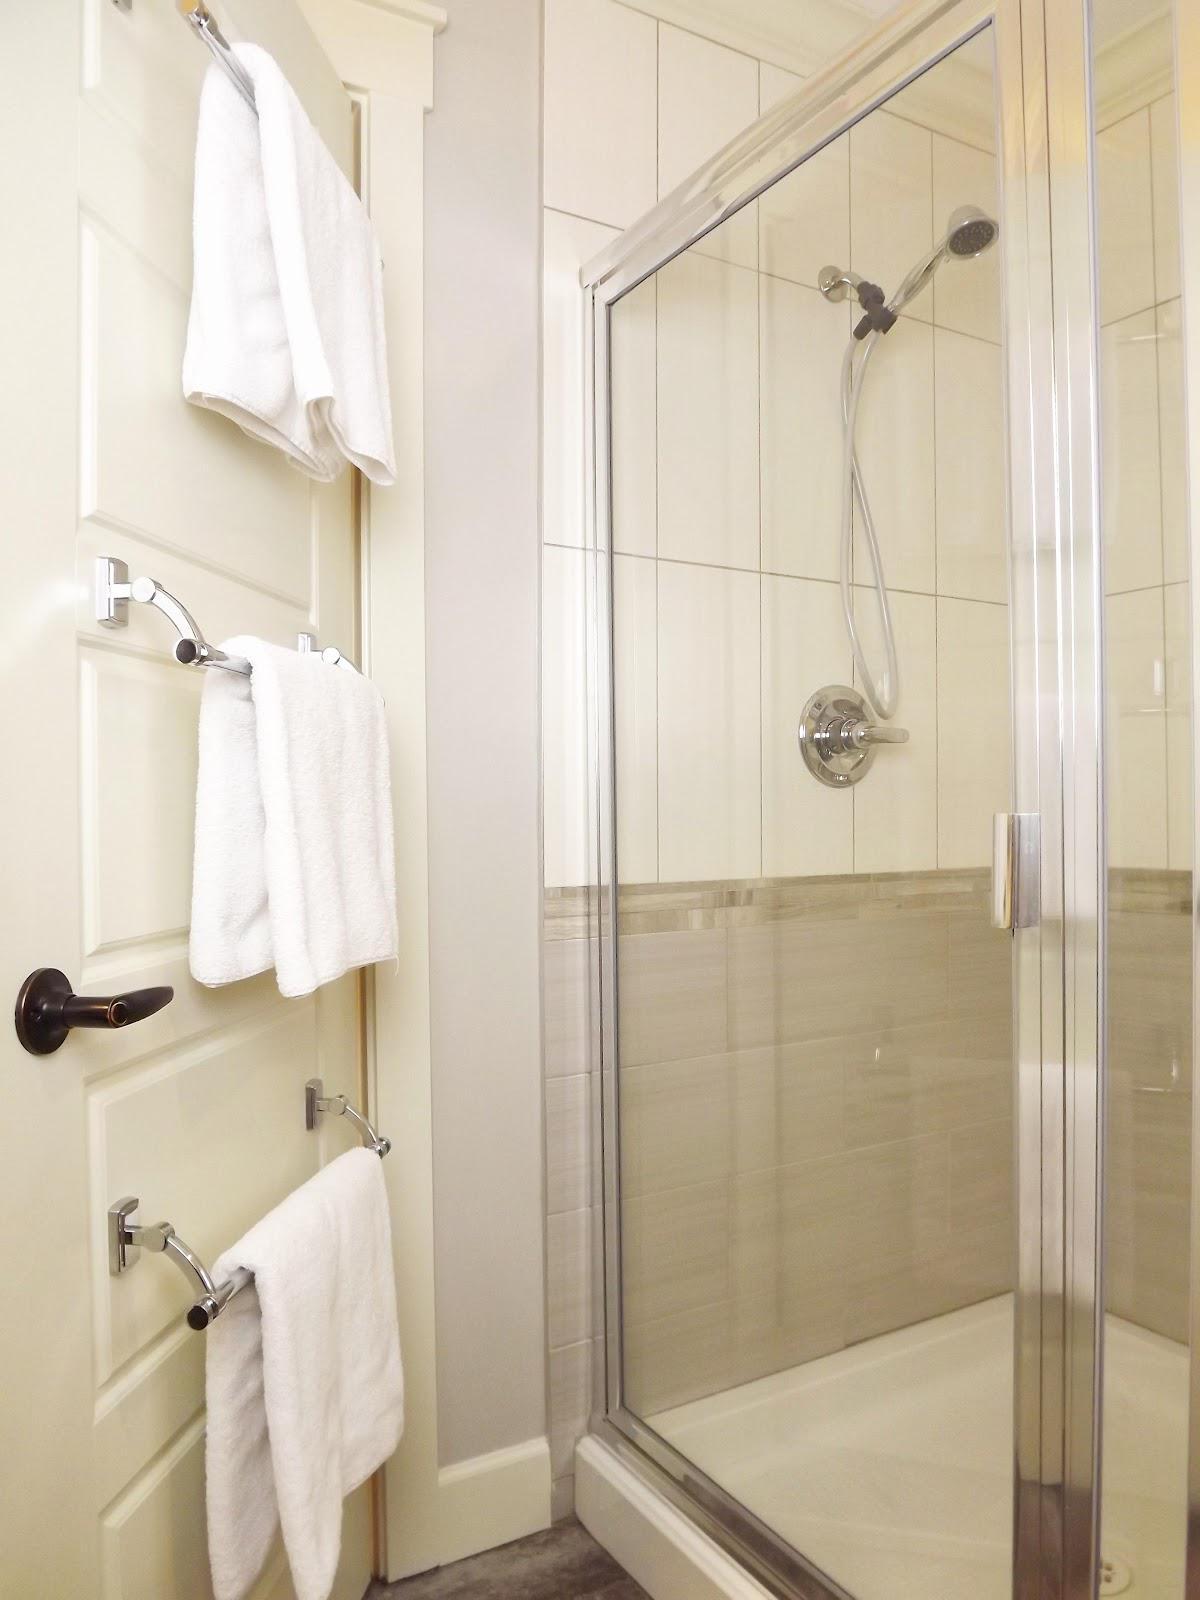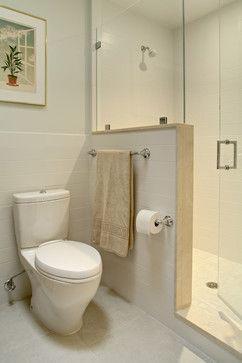The first image is the image on the left, the second image is the image on the right. For the images shown, is this caption "There are two sinks." true? Answer yes or no. No. The first image is the image on the left, the second image is the image on the right. Examine the images to the left and right. Is the description "There is a toilet in one image and a shower in the other." accurate? Answer yes or no. Yes. 